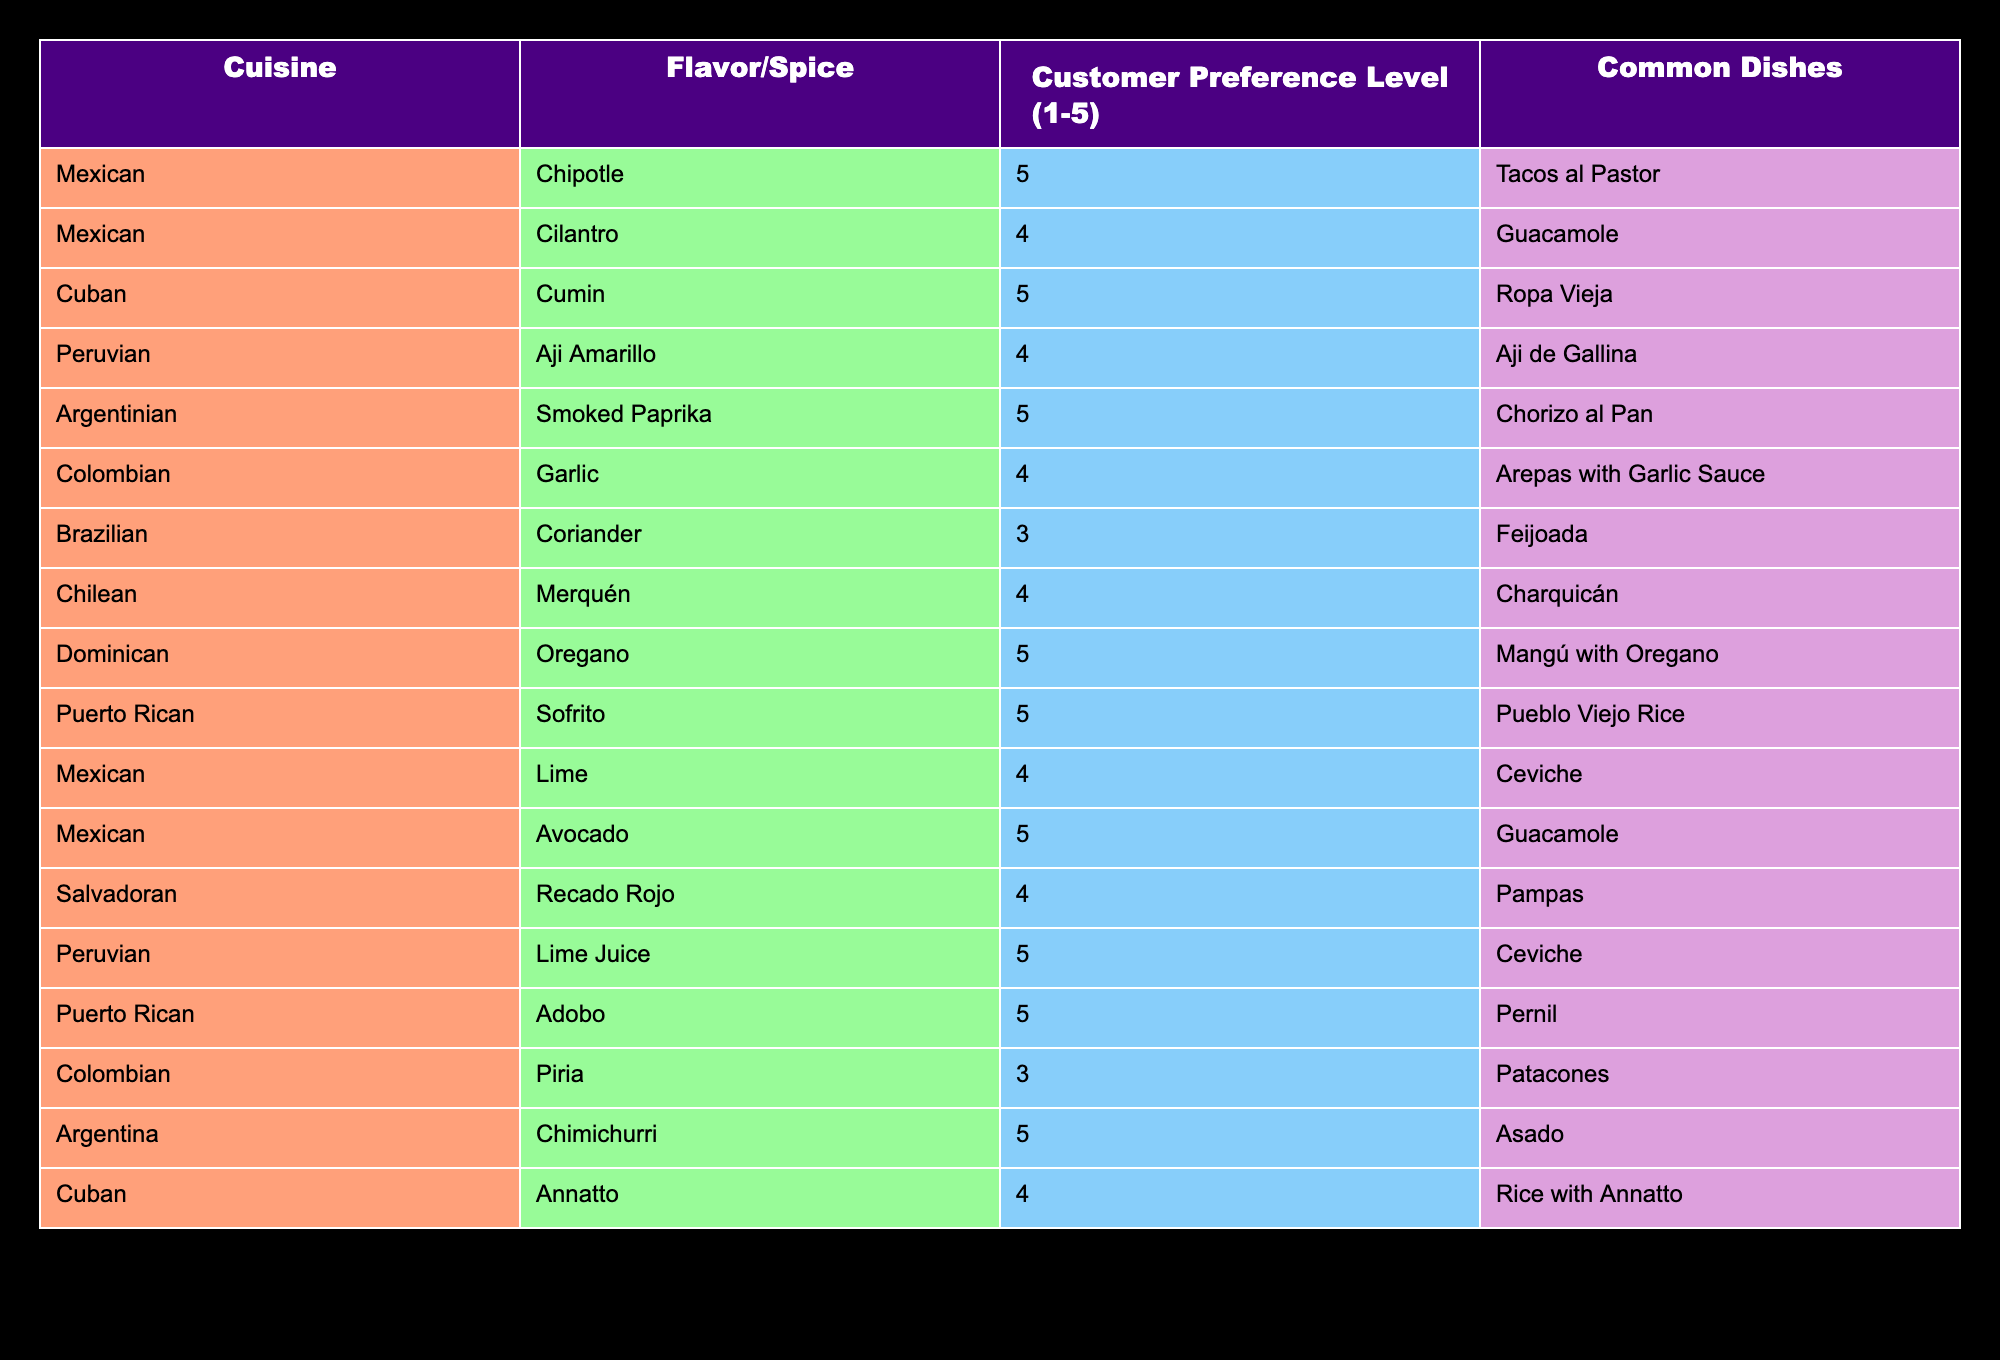What is the highest customer preference level for a spice in the table? The table lists various spices along with their customer preference levels. The highest preference level recorded is 5. Looking through the table, both Chipotle, Cumin, Smoked Paprika, Oregano, Sofrito, Lime Juice, Adobo, and Chimichurri have a customer preference level of 5.
Answer: 5 Which cuisine has the most spices with a preference level of 5? By examining the preference levels for each cuisine, I see that the Mexican, Cuban, Dominican, Puerto Rican, and Argentinian cuisines each have spices with a preference level of 5. In total, there are 8 instances of preference level 5 across these cuisines. Mexican cuisine has four entries: Chipotle, Avocado, Lime, and Cilantro. Therefore, Mexican cuisine is tied with Cuban, Dominican, Puerto Rican, and Argentinian for the most spices with a preference level of 5.
Answer: Mexican, Cuban, Dominican, Puerto Rican, and Argentinian Are there any spice preferences rated below 3? A review of the customer preference levels in the table shows that all the spices have ratings between 1 and 5, with the lowest rating listed as 3 for Coriander and Piria. Thus, there are no spices with ratings below 3 present in the table.
Answer: No What is the average customer preference level for the Peruvian cuisine? Focusing on the Peruvian spices listed, Aji Amarillo has a preference level of 4, and Lime Juice has a preference level of 5. To calculate the average, I sum these values: 4 + 5 = 9. There are 2 data points, hence, 9/2 = 4.5. Therefore, the average customer preference level for Peruvian cuisine is 4.5.
Answer: 4.5 Which dishes commonly use the spice "Cilantro"? The table indicates that Cilantro is specifically associated with Guacamole, and its preference level is 4. Therefore, the only dish listed that utilizes Cilantro is Guacamole.
Answer: Guacamole 